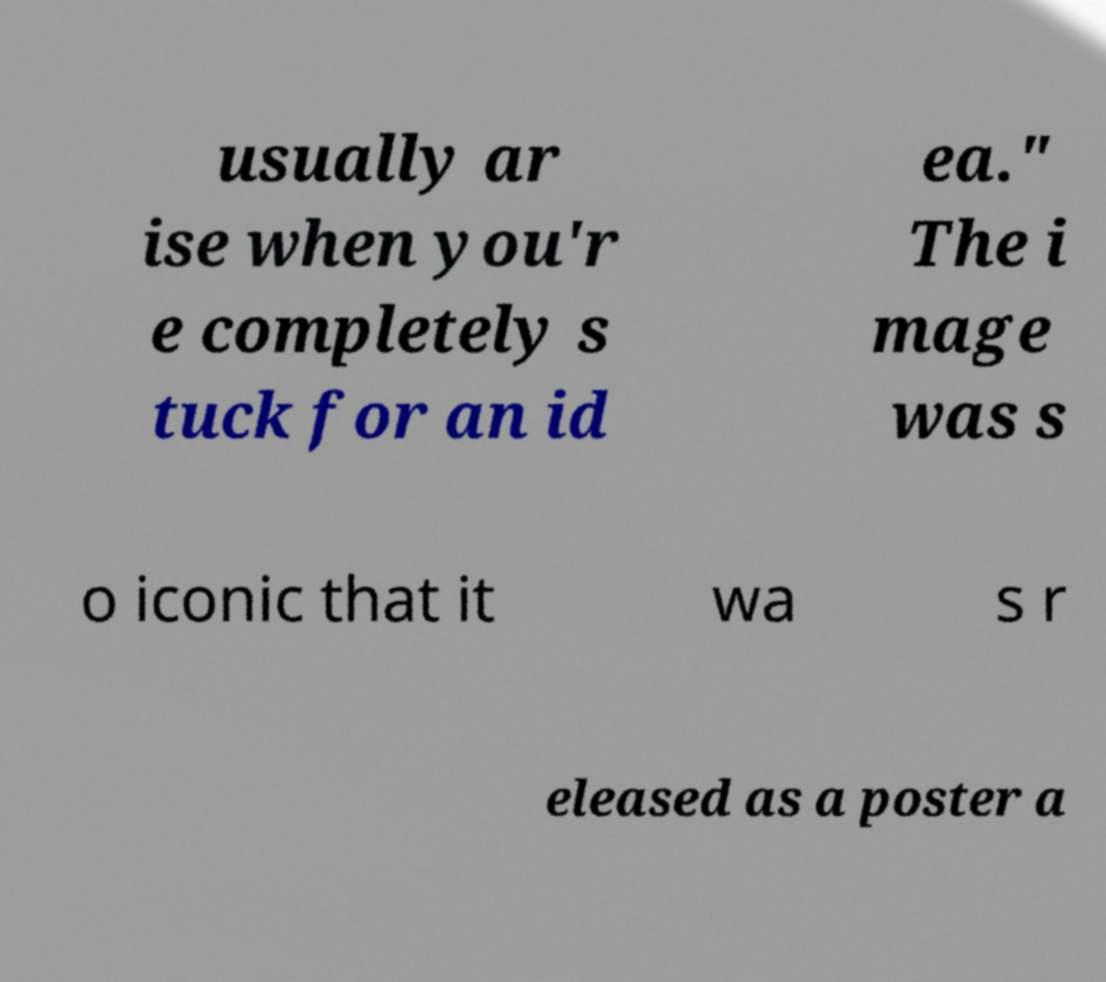I need the written content from this picture converted into text. Can you do that? usually ar ise when you'r e completely s tuck for an id ea." The i mage was s o iconic that it wa s r eleased as a poster a 